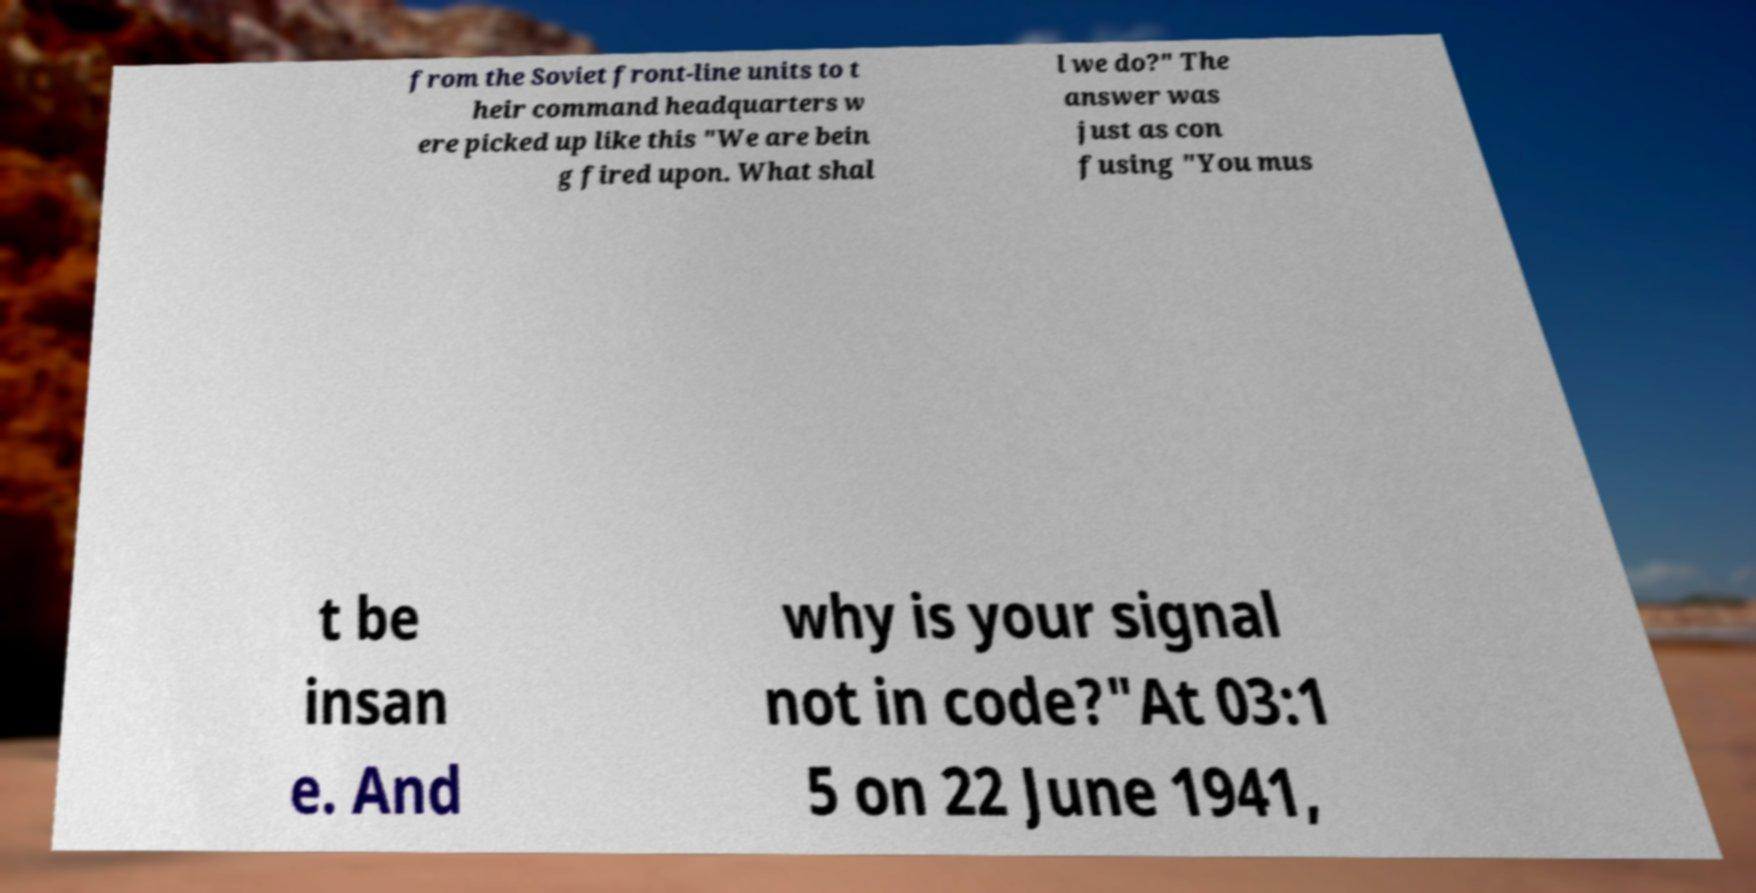What messages or text are displayed in this image? I need them in a readable, typed format. from the Soviet front-line units to t heir command headquarters w ere picked up like this "We are bein g fired upon. What shal l we do?" The answer was just as con fusing "You mus t be insan e. And why is your signal not in code?"At 03:1 5 on 22 June 1941, 